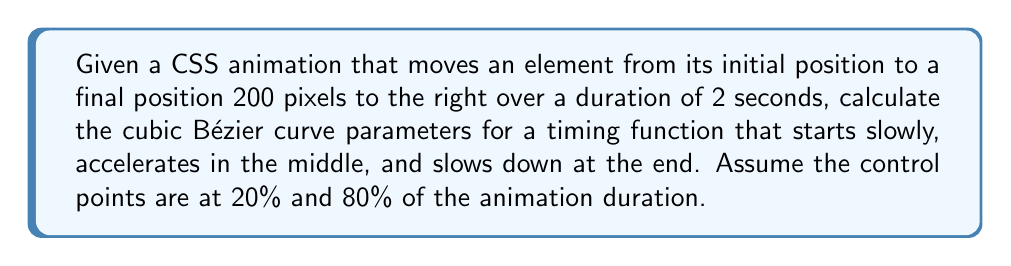Provide a solution to this math problem. To solve this problem, we need to understand the cubic Bézier curve equation and how it relates to CSS animation timing functions. The cubic Bézier curve is defined by four points: P0, P1, P2, and P3.

1. P0 (0,0) and P3 (1,1) are fixed for CSS animations.
2. We need to determine P1 (x1, y1) and P2 (x2, y2).

Given:
- Animation duration: 2 seconds
- Control points at 20% and 80% of the duration

Step 1: Calculate x-coordinates of control points
x1 = 20% of duration = 0.2
x2 = 80% of duration = 0.8

Step 2: Determine y-coordinates based on desired acceleration
- For a slow start: y1 should be close to 0
- For acceleration in the middle: y2 should be higher than x2
- For slowing down at the end: y2 should be less than 1

Let's choose:
y1 = 0.1 (slow start)
y2 = 0.9 (fast middle, slowing end)

Step 3: Write the cubic Bézier function
The cubic Bézier curve is defined by the parametric equations:

$$ x(t) = (1-t)^3x_0 + 3(1-t)^2tx_1 + 3(1-t)t^2x_2 + t^3x_3 $$
$$ y(t) = (1-t)^3y_0 + 3(1-t)^2ty_1 + 3(1-t)t^2y_2 + t^3y_3 $$

Where t is the time parameter ranging from 0 to 1.

Step 4: Simplify for CSS timing function
In CSS, we only need to specify P1 and P2, as P0 and P3 are fixed. The timing function is written as:

cubic-bezier(x1, y1, x2, y2)

Therefore, our timing function is:
cubic-bezier(0.2, 0.1, 0.8, 0.9)
Answer: cubic-bezier(0.2, 0.1, 0.8, 0.9) 